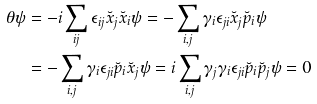Convert formula to latex. <formula><loc_0><loc_0><loc_500><loc_500>\theta \psi & = - i \sum _ { i j } \epsilon _ { i j } \breve { x } _ { j } \breve { x } _ { i } \psi = - \sum _ { i , j } \gamma _ { i } \epsilon _ { j i } \breve { x } _ { j } \breve { p } _ { i } \psi \\ & = - \sum _ { i , j } \gamma _ { i } \epsilon _ { j i } \breve { p } _ { i } \breve { x } _ { j } \psi = i \sum _ { i , j } \gamma _ { j } \gamma _ { i } \epsilon _ { j i } \breve { p } _ { i } \breve { p } _ { j } \psi = 0</formula> 